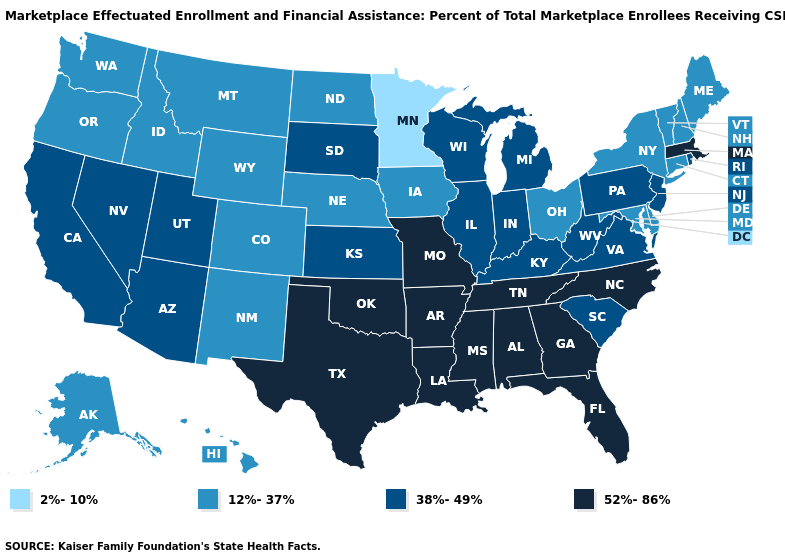Among the states that border Connecticut , does Massachusetts have the highest value?
Give a very brief answer. Yes. Does Ohio have a lower value than Washington?
Give a very brief answer. No. How many symbols are there in the legend?
Answer briefly. 4. Does Mississippi have the highest value in the USA?
Concise answer only. Yes. Does the map have missing data?
Answer briefly. No. What is the value of California?
Give a very brief answer. 38%-49%. Which states hav the highest value in the South?
Write a very short answer. Alabama, Arkansas, Florida, Georgia, Louisiana, Mississippi, North Carolina, Oklahoma, Tennessee, Texas. What is the value of Montana?
Quick response, please. 12%-37%. What is the value of Michigan?
Quick response, please. 38%-49%. What is the value of Tennessee?
Write a very short answer. 52%-86%. What is the value of Connecticut?
Quick response, please. 12%-37%. What is the highest value in states that border North Dakota?
Concise answer only. 38%-49%. Name the states that have a value in the range 2%-10%?
Quick response, please. Minnesota. How many symbols are there in the legend?
Quick response, please. 4. Does the map have missing data?
Write a very short answer. No. 